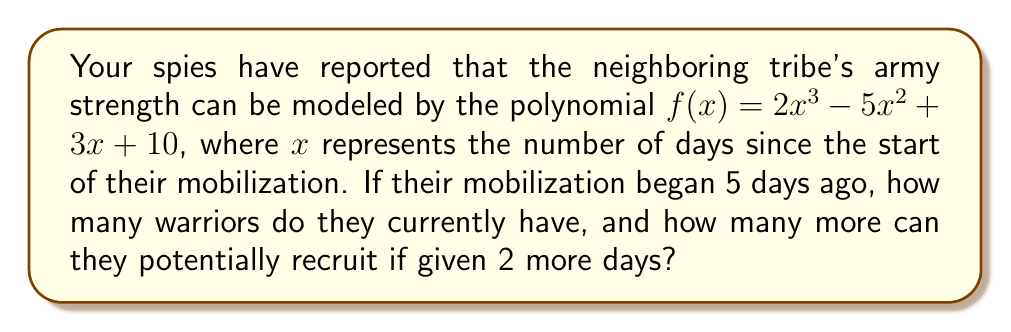Solve this math problem. 1. Calculate the current army strength:
   - Substitute $x = 5$ into $f(x) = 2x^3 - 5x^2 + 3x + 10$
   $$f(5) = 2(5^3) - 5(5^2) + 3(5) + 10$$
   $$= 2(125) - 5(25) + 15 + 10$$
   $$= 250 - 125 + 15 + 10$$
   $$= 150$$

2. Calculate the potential army strength in 2 days:
   - Substitute $x = 7$ into $f(x) = 2x^3 - 5x^2 + 3x + 10$
   $$f(7) = 2(7^3) - 5(7^2) + 3(7) + 10$$
   $$= 2(343) - 5(49) + 21 + 10$$
   $$= 686 - 245 + 21 + 10$$
   $$= 472$$

3. Calculate the difference in army strength:
   $$472 - 150 = 322$$

Therefore, the neighboring tribe currently has 150 warriors and can potentially recruit 322 more warriors in the next 2 days.
Answer: 150 warriors now; 322 more in 2 days 